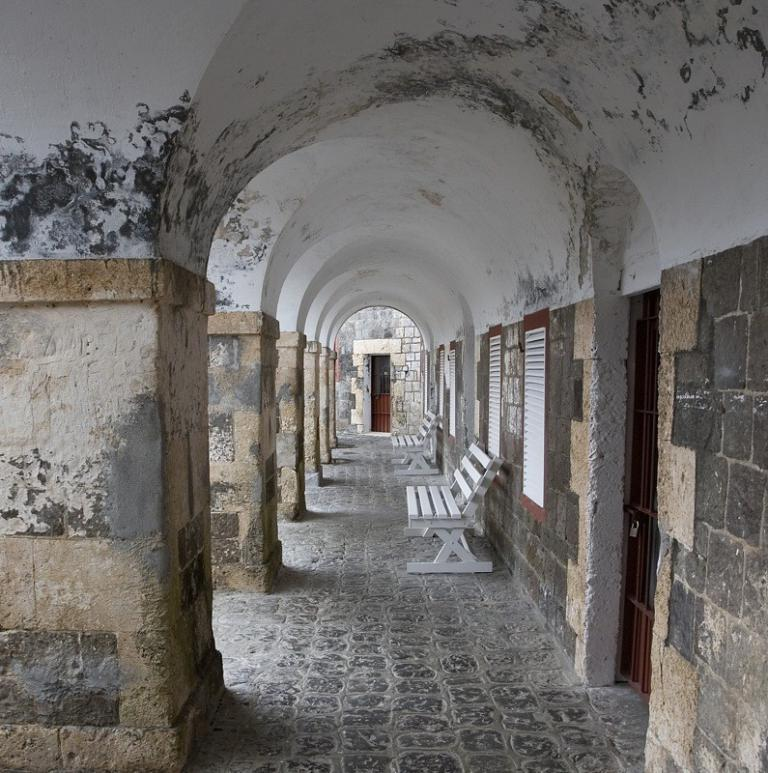What part of a building is shown in the image? The image shows the inner part of a building. What type of barrier can be seen in the image? There is a gate in the image. How is the gate secured in the image? A lock is present in the image. What architectural features are visible in the image? There are windows and pillars visible in the image. What type of furniture is present in the image? Benches are present in the image. How many clocks are hanging on the pillars in the image? There are no clocks visible in the image; only a gate, lock, windows, pillars, and benches are present. What type of hose is connected to the windows in the image? There is no hose connected to the windows in the image; only a gate, lock, windows, pillars, and benches are present. 